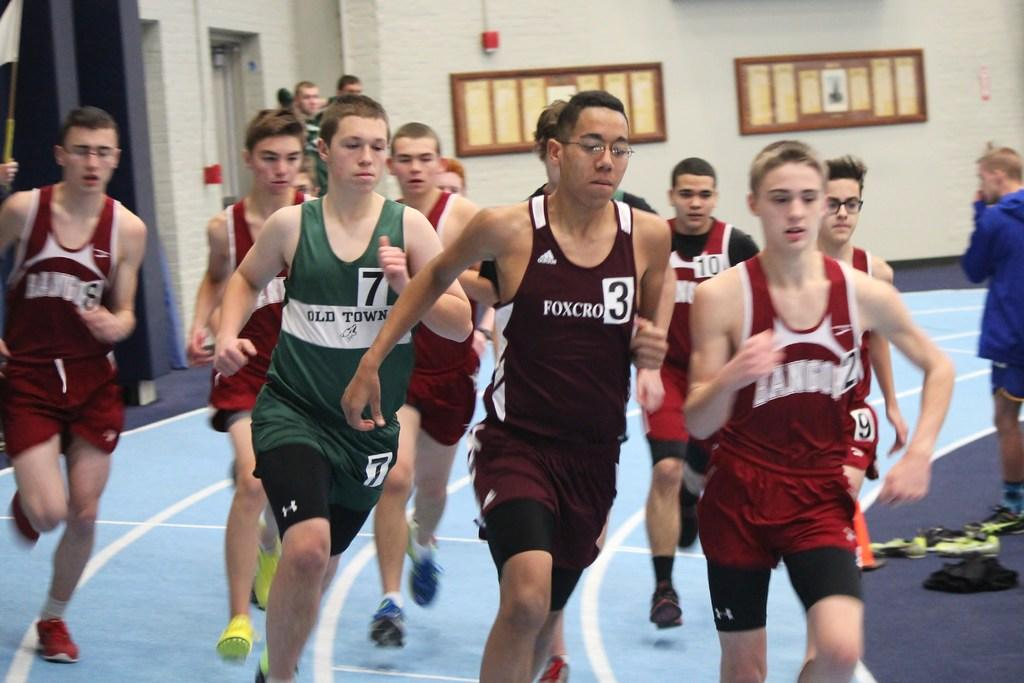How many people are present in the image? There are many people in the image. What are the people doing in the image? The people are running. What type of clothing are the people wearing? The people are wearing sports dress. What can be seen at the bottom of the image? There is ground visible at the bottom of the image. What is visible in the background of the image? There is a wall in the background of the image, and boards are fixed on the wall. What type of pencil is being used by the people in the image? There is no pencil present in the image; the people are running and wearing sports dress. What is the aftermath of the race in the image? The image does not show the aftermath of a race; it only shows people running. 